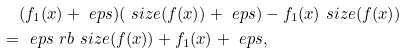Convert formula to latex. <formula><loc_0><loc_0><loc_500><loc_500>& ( f _ { 1 } ( x ) + \ e p s ) ( \ s i z e ( f ( x ) ) + \ e p s ) - f _ { 1 } ( x ) \ s i z e ( f ( x ) ) \\ = & \ \ e p s \ r b { \ s i z e ( f ( x ) ) + f _ { 1 } ( x ) + \ e p s } ,</formula> 